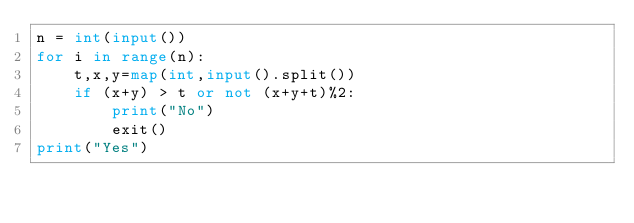Convert code to text. <code><loc_0><loc_0><loc_500><loc_500><_Python_>n = int(input())
for i in range(n):
    t,x,y=map(int,input().split())
    if (x+y) > t or not (x+y+t)%2:
        print("No")
        exit()
print("Yes")
</code> 